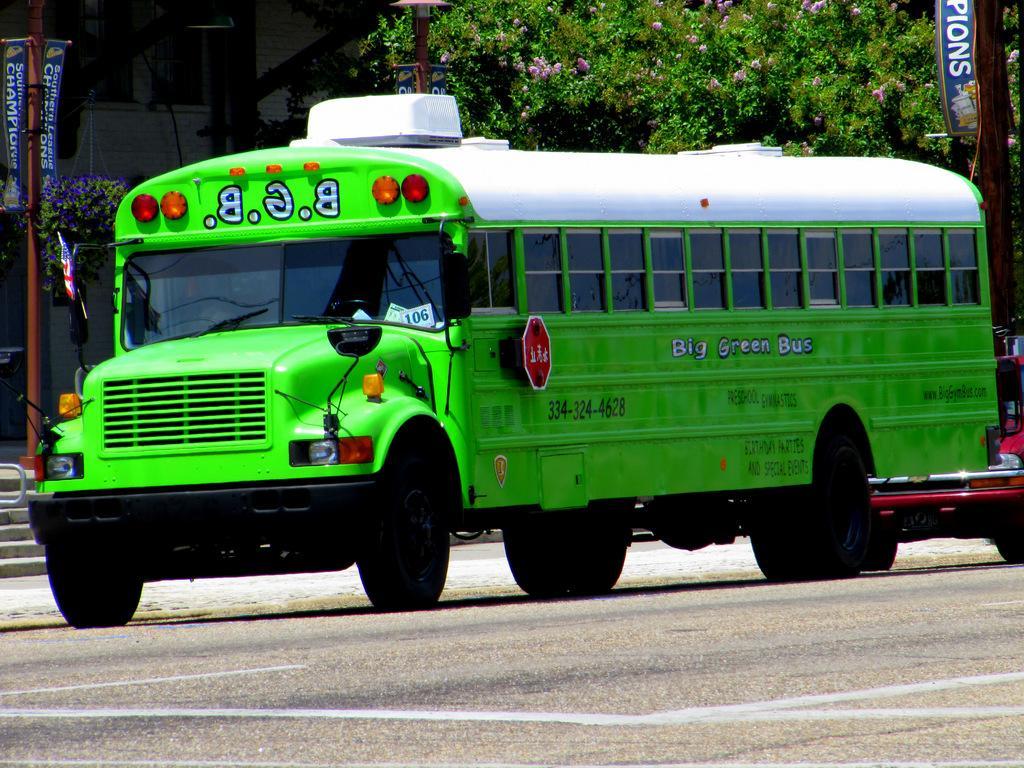Please provide a concise description of this image. This picture shows bus and a ace on the road. Bus is green and white in color and we see a building and a tree and couple of banners to the poles and car is red in color. 